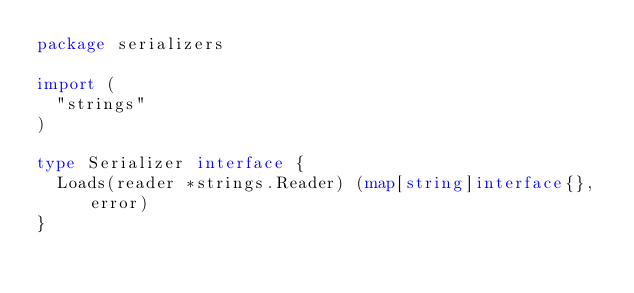<code> <loc_0><loc_0><loc_500><loc_500><_Go_>package serializers

import (
	"strings"
)

type Serializer interface {
	Loads(reader *strings.Reader) (map[string]interface{}, error)
}
</code> 